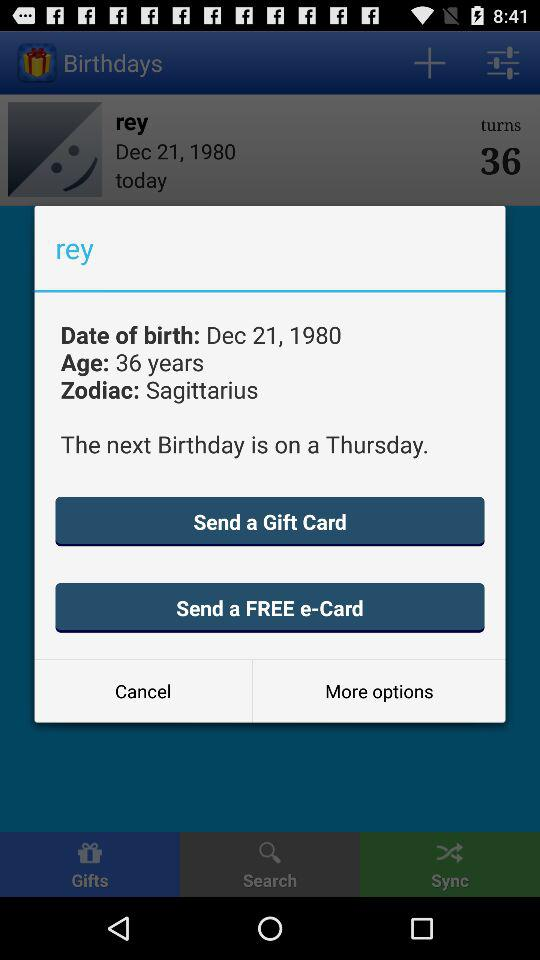What is the Zodiac sign of Rey? The Zodiac sign of Rey is "Sagittarius". 